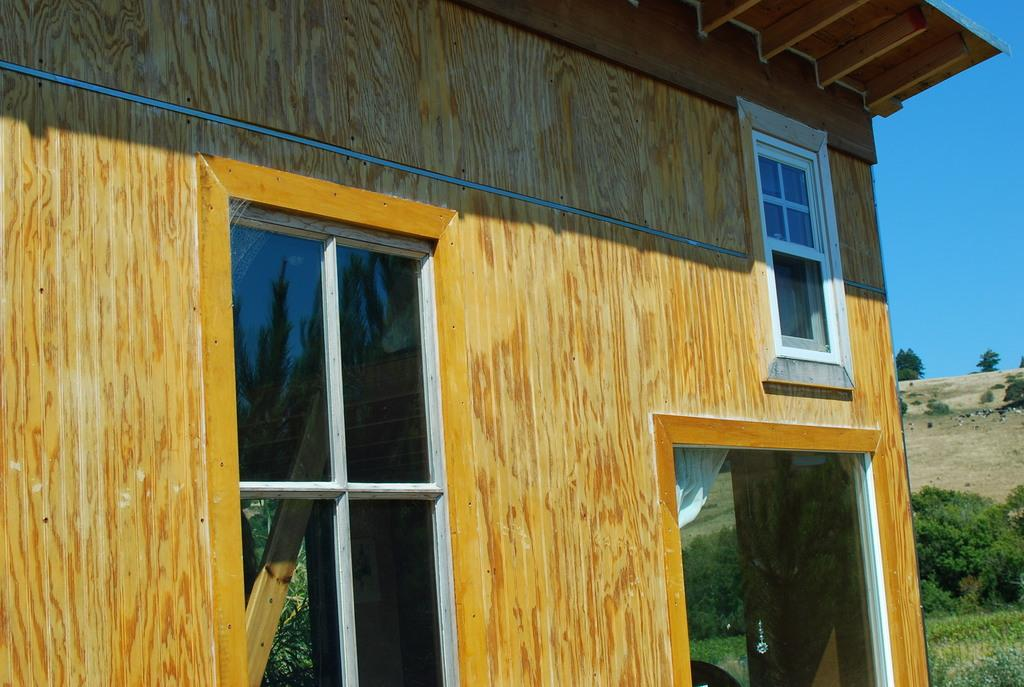What type of structure is in the image? There is a house in the image. What feature can be seen on the house? The house has glass windows. What can be seen on the right side of the image? There are plants and grass on a hill to the right of the house. What is visible in the top right of the image? The sky is visible in the top right of the image. What type of skate is being used by the mom in the image? There is no skate or mom present in the image. How many attempts did the person make to climb the hill in the image? There is no person attempting to climb a hill in the image. 